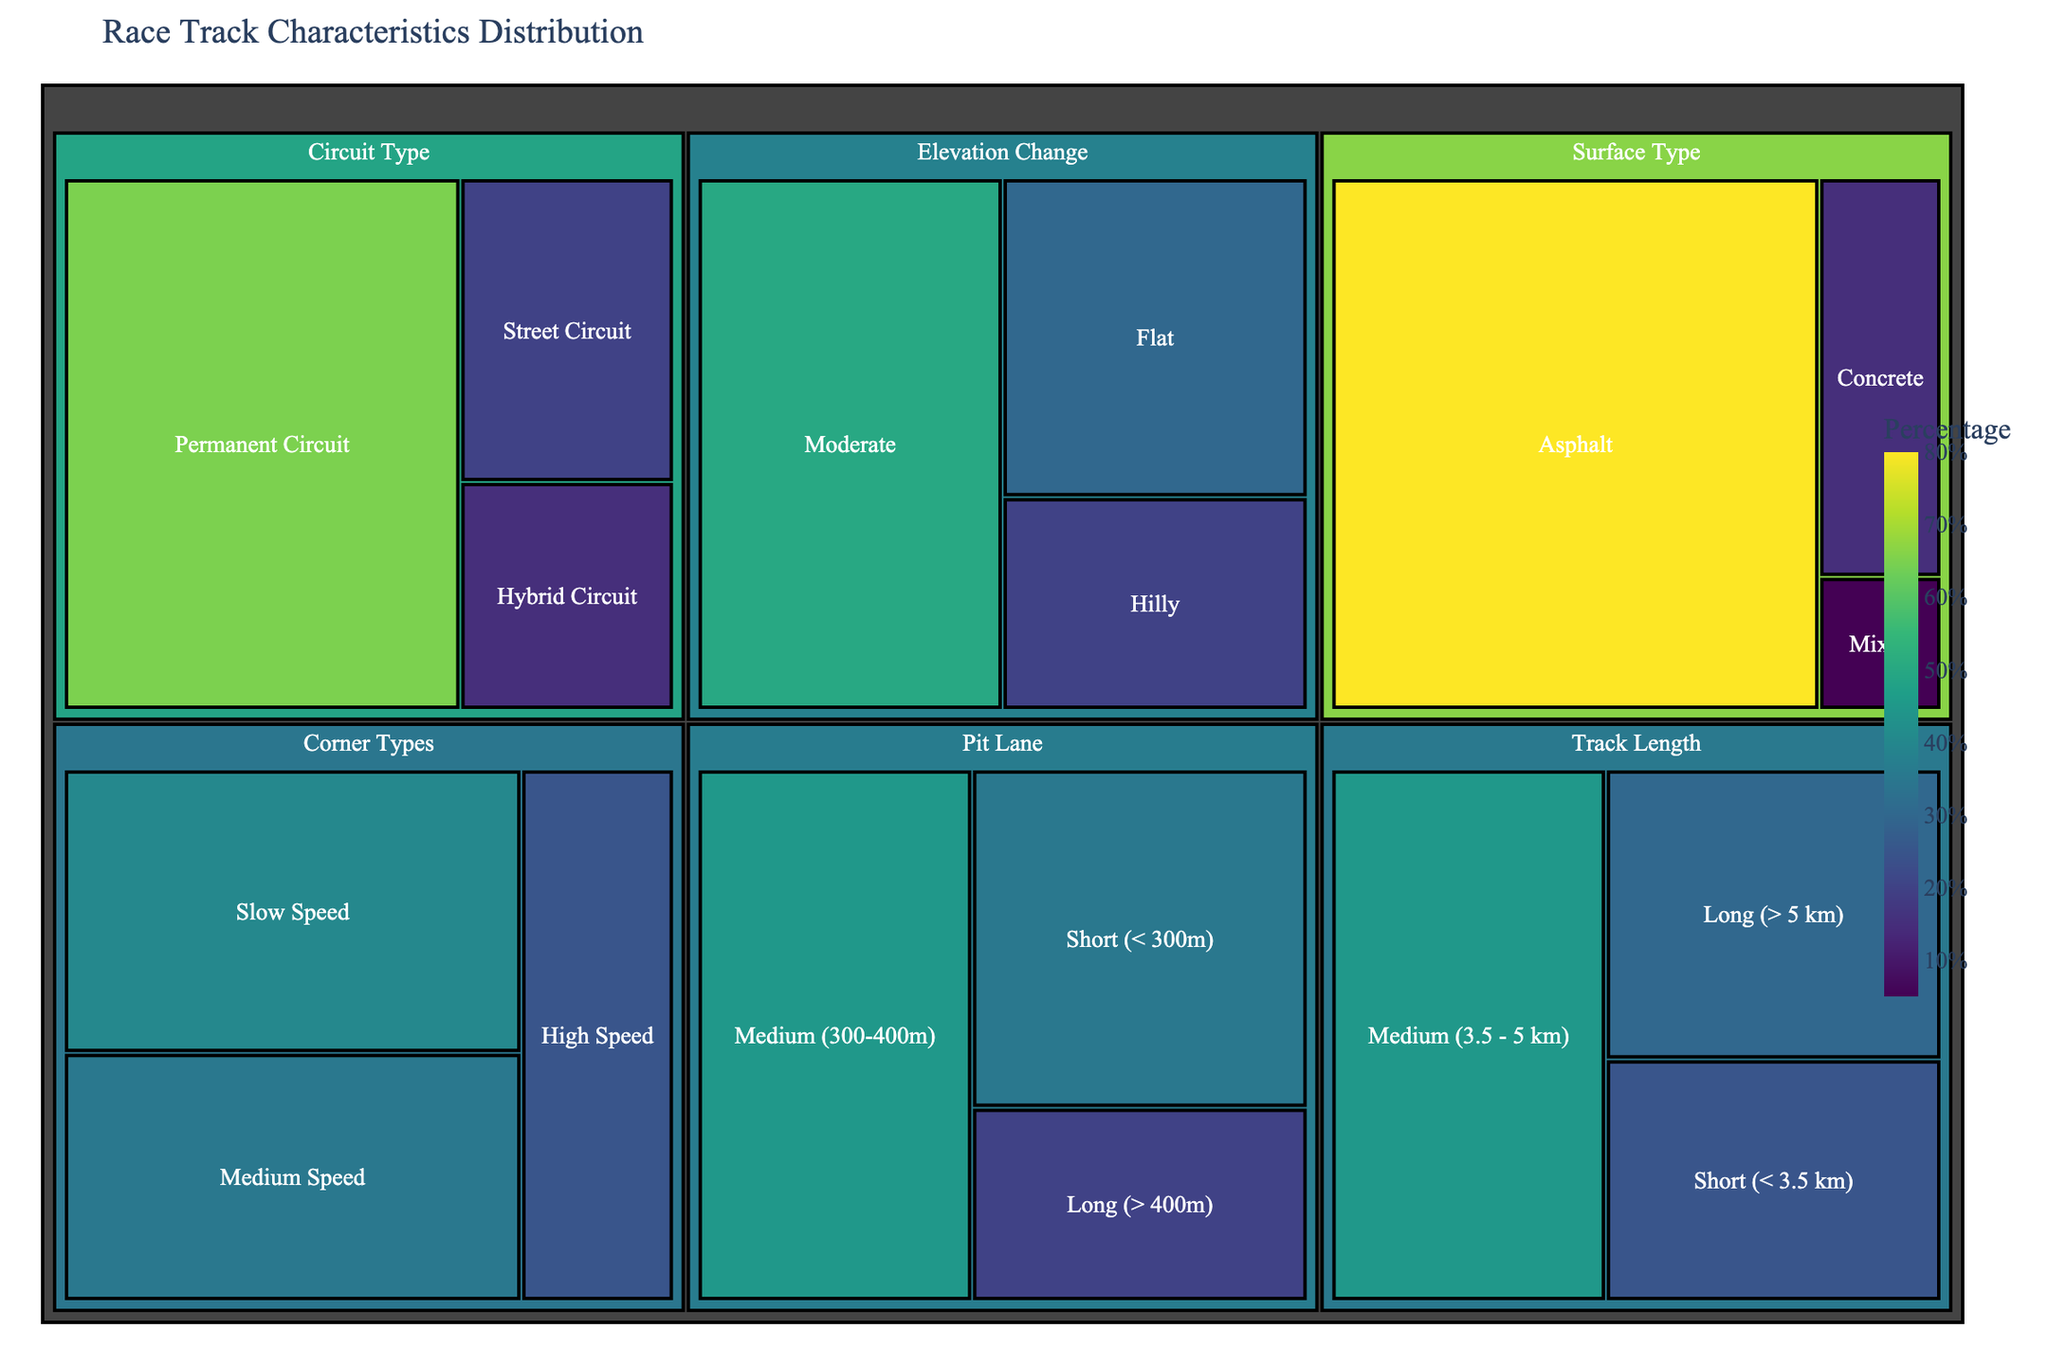What is the title of the treemap? The title of the treemap is usually placed at the top of the figure. Reading from the top, the title is "Race Track Characteristics Distribution".
Answer: Race Track Characteristics Distribution Which subcategory has the highest value in the "Surface Type" category? In the "Surface Type" category, the values are 80 for Asphalt, 15 for Concrete, and 5 for Mixed. The highest value is for Asphalt.
Answer: Asphalt Between "Medium (3.5 - 5 km)" and "Long (> 5 km)" under the "Track Length" category, which one has a higher percentage? Comparing the values under "Track Length," "Medium (3.5 - 5 km)" has 45, while "Long (> 5 km)" has 30. Thus, "Medium (3.5 - 5 km)" has a higher percentage.
Answer: Medium (3.5 - 5 km) What is the combined percentage for all subcategories under the "Circuit Type" category? To find the combined percentage, add the values for Street Circuit (20), Permanent Circuit (65), and Hybrid Circuit (15). The sum is 100.
Answer: 100 Which "Elevation Change" subcategory has the smallest value? In the "Elevation Change" category, the values are 30 for Flat, 50 for Moderate, and 20 for Hilly. The smallest value is for Hilly.
Answer: Hilly How many subcategories fall under the "Corner Types" category? Count the subcategories listed under "Corner Types." There are Slow Speed, Medium Speed, and High Speed, making it three subcategories.
Answer: 3 Compare "Short (< 300m)" pit lanes to "Long (> 400m)" pit lanes. which one is more prevalent? The values for "Short (< 300m)" is 35 and for "Long (> 400m)" is 20. "Short (< 300m)" pit lanes are more prevalent.
Answer: Short (< 300m) What is the most common track length category? From the categories, Medium (3.5 - 5 km) has the highest value of 45, making it the most common track length category.
Answer: Medium (3.5 - 5 km) What percentage of circuits have a "Permanent Circuit" type? The value for Permanent Circuit under the "Circuit Type" category is 65, meaning 65% of the circuits are Permanent Circuits.
Answer: 65 What is the total percentage of circuits with either a "Street Circuit" or "Hybrid Circuit" type? Add the values for Street Circuit (20) and Hybrid Circuit (15) under "Circuit Type". The total is 35.
Answer: 35 